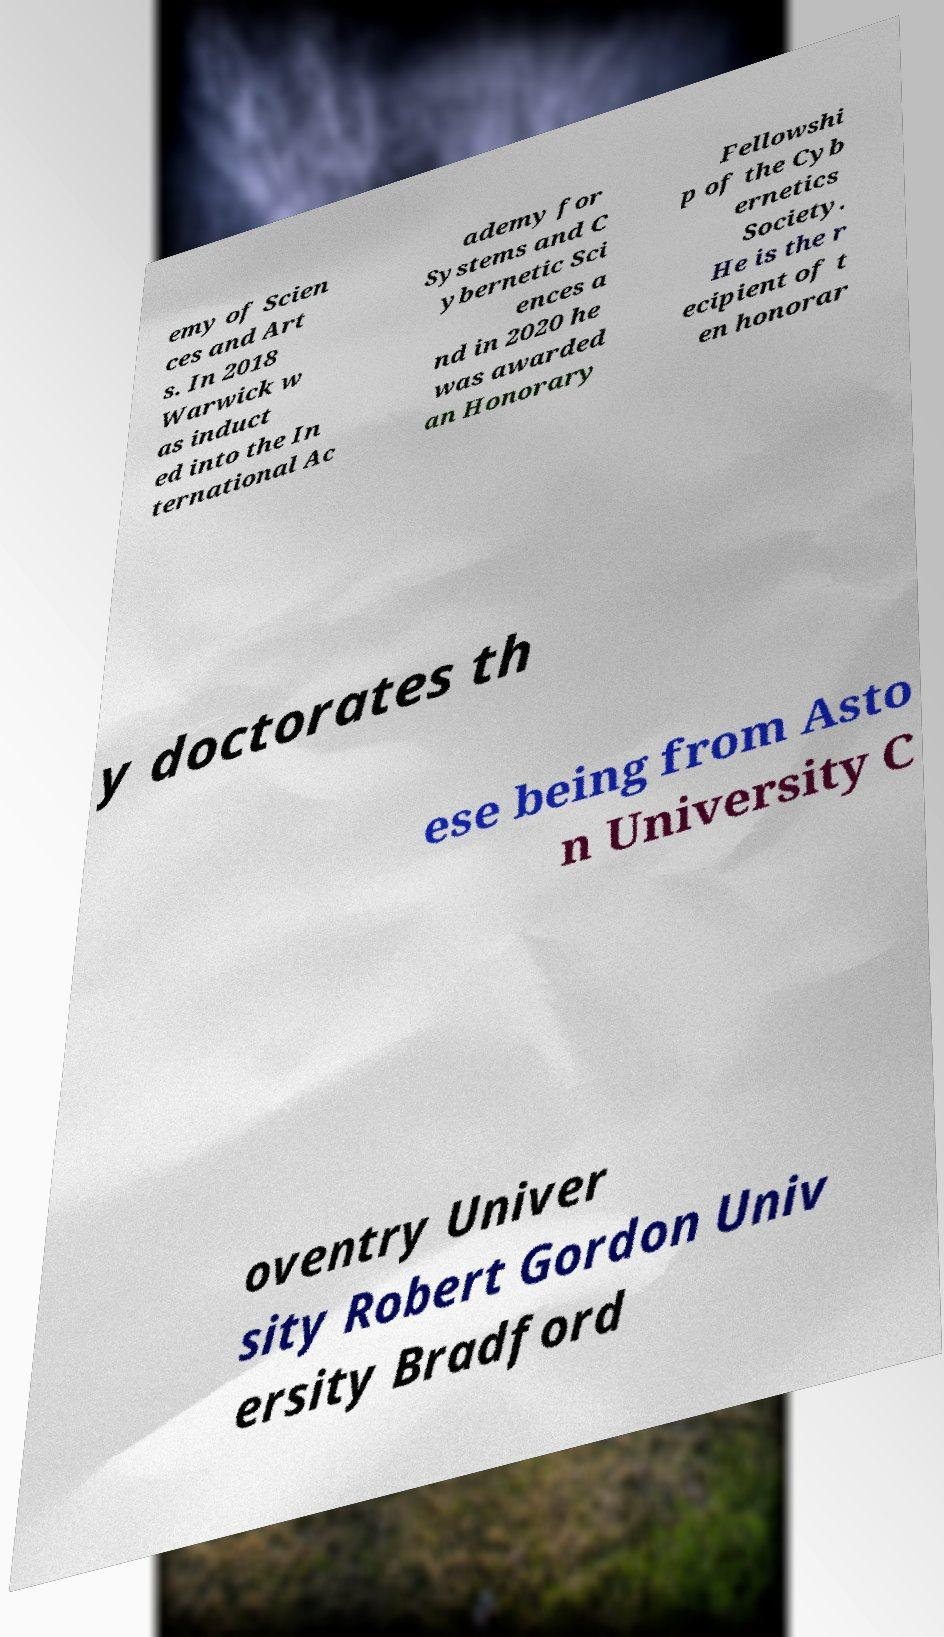Could you assist in decoding the text presented in this image and type it out clearly? emy of Scien ces and Art s. In 2018 Warwick w as induct ed into the In ternational Ac ademy for Systems and C ybernetic Sci ences a nd in 2020 he was awarded an Honorary Fellowshi p of the Cyb ernetics Society. He is the r ecipient of t en honorar y doctorates th ese being from Asto n University C oventry Univer sity Robert Gordon Univ ersity Bradford 